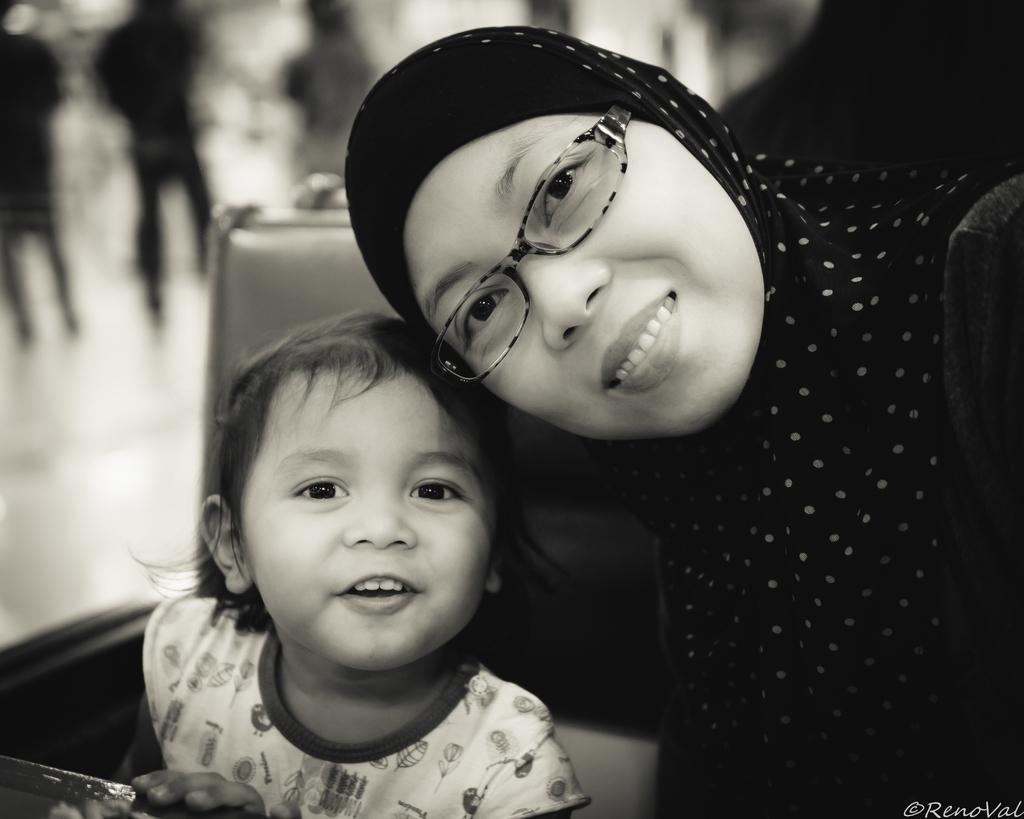Can you describe this image briefly? This picture describes about group of people, on the right side of the image we can see a woman, she wore spectacles and she is smiling, beside to her we can see a kid, and also we can see a watermark at the right bottom of the image. 